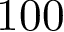<formula> <loc_0><loc_0><loc_500><loc_500>1 0 0</formula> 